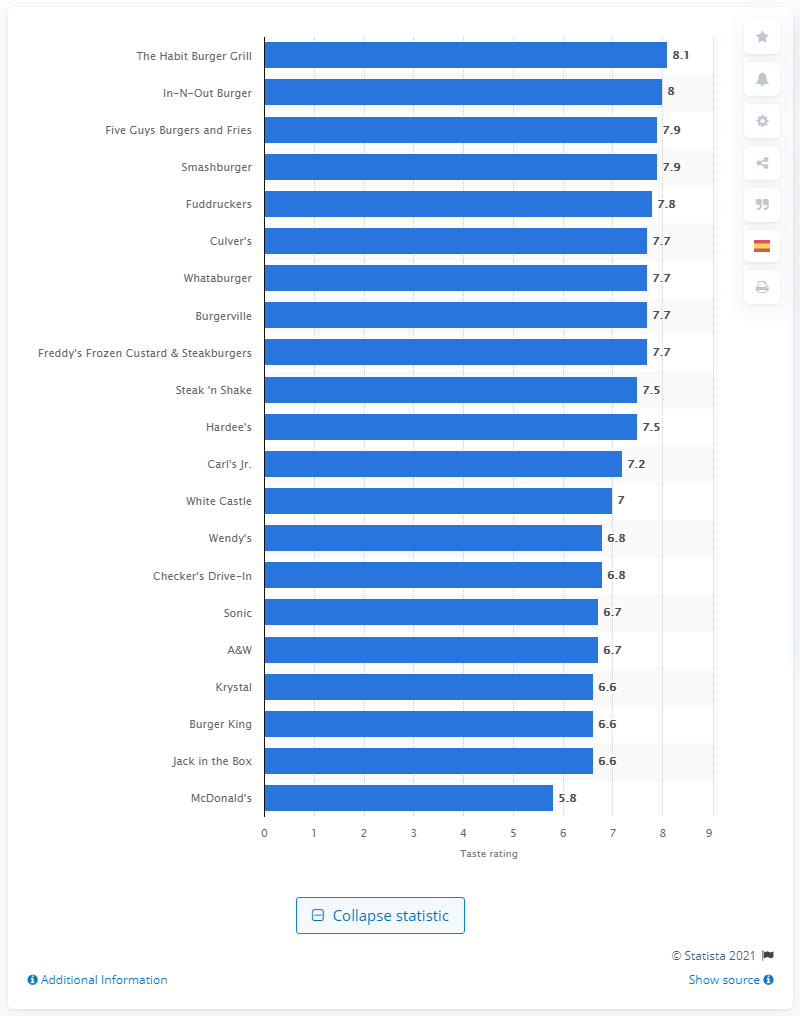Specify some key components in this picture. According to a rating of Five Guys Burger and Fries, it received a score of 7.9. 